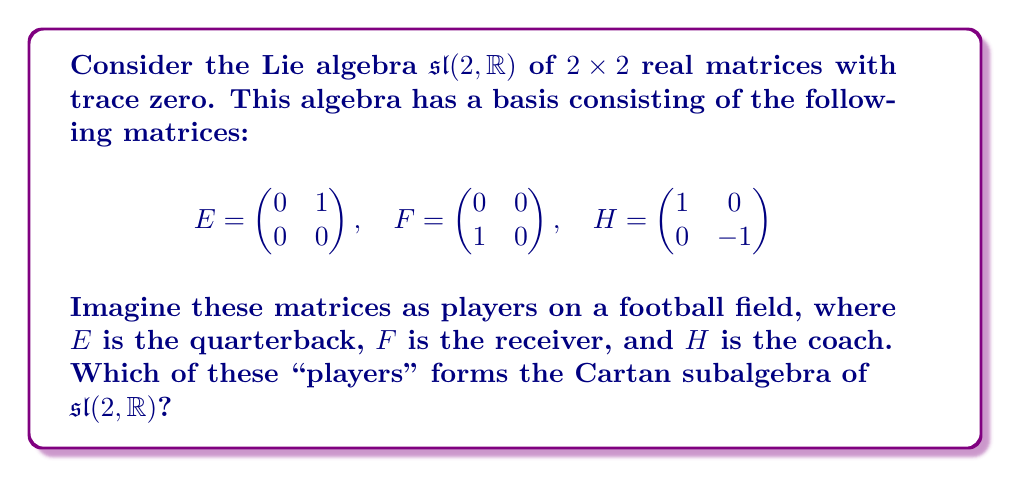Teach me how to tackle this problem. Let's approach this step-by-step:

1) First, recall that a Cartan subalgebra is a maximal abelian subalgebra consisting of semisimple elements.

2) In $\mathfrak{sl}(2, \mathbb{R})$, we need to check which of these matrices commute with each other and are diagonalizable.

3) Let's check the commutators:
   
   $[E,F] = EF - FE = H$
   $[E,H] = EH - HE = 2E$
   $[F,H] = FH - HF = -2F$

4) We see that $E$ and $F$ don't commute with any other basis element.

5) However, $H$ commutes with itself (as all elements do).

6) Moreover, $H$ is already in diagonal form, so it's semisimple.

7) Any larger abelian subalgebra would have to include either $E$ or $F$, but we've seen that these don't commute with $H$.

Therefore, the one-dimensional subalgebra spanned by $H$ is the Cartan subalgebra of $\mathfrak{sl}(2, \mathbb{R})$.

In our football analogy, the "coach" $H$ forms the Cartan subalgebra.
Answer: $\text{span}\{H\}$ 